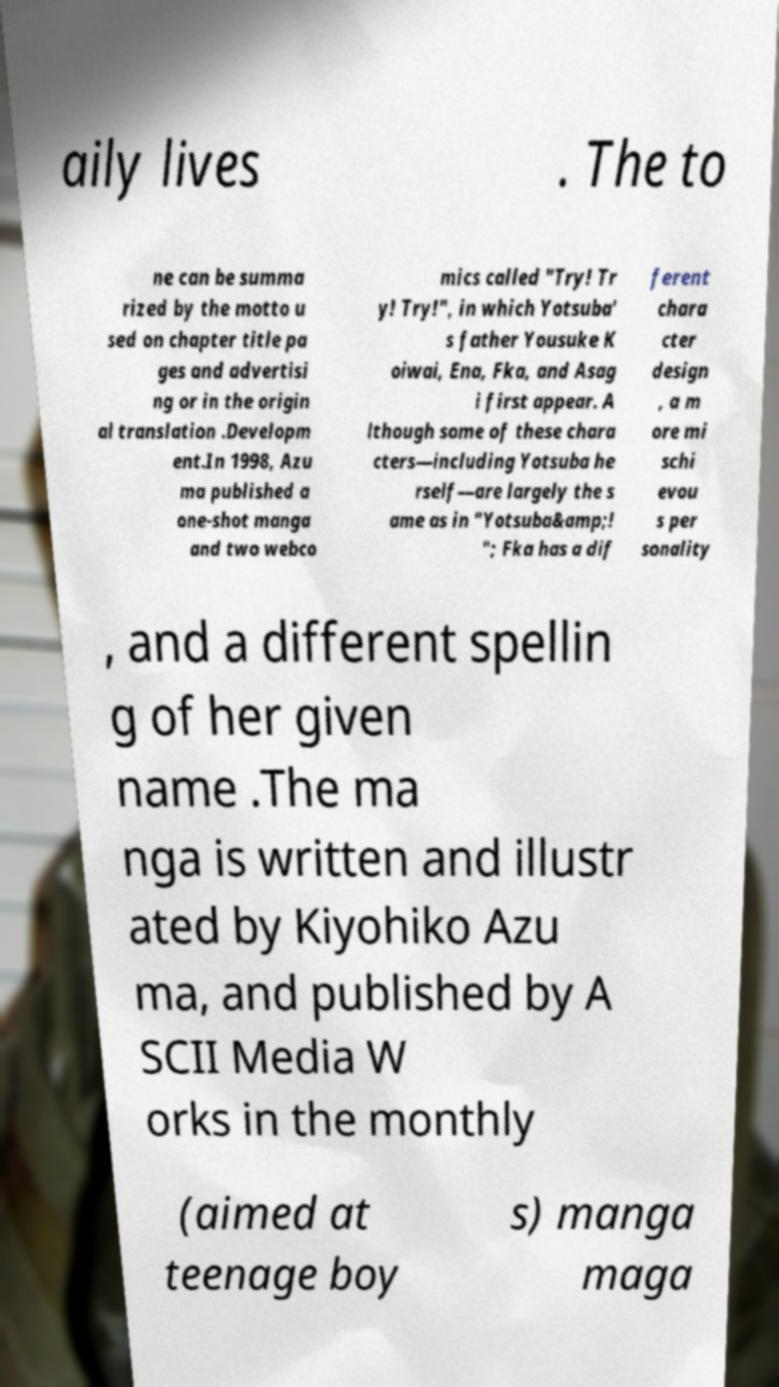Can you accurately transcribe the text from the provided image for me? aily lives . The to ne can be summa rized by the motto u sed on chapter title pa ges and advertisi ng or in the origin al translation .Developm ent.In 1998, Azu ma published a one-shot manga and two webco mics called "Try! Tr y! Try!", in which Yotsuba' s father Yousuke K oiwai, Ena, Fka, and Asag i first appear. A lthough some of these chara cters—including Yotsuba he rself—are largely the s ame as in "Yotsuba&amp;! "; Fka has a dif ferent chara cter design , a m ore mi schi evou s per sonality , and a different spellin g of her given name .The ma nga is written and illustr ated by Kiyohiko Azu ma, and published by A SCII Media W orks in the monthly (aimed at teenage boy s) manga maga 